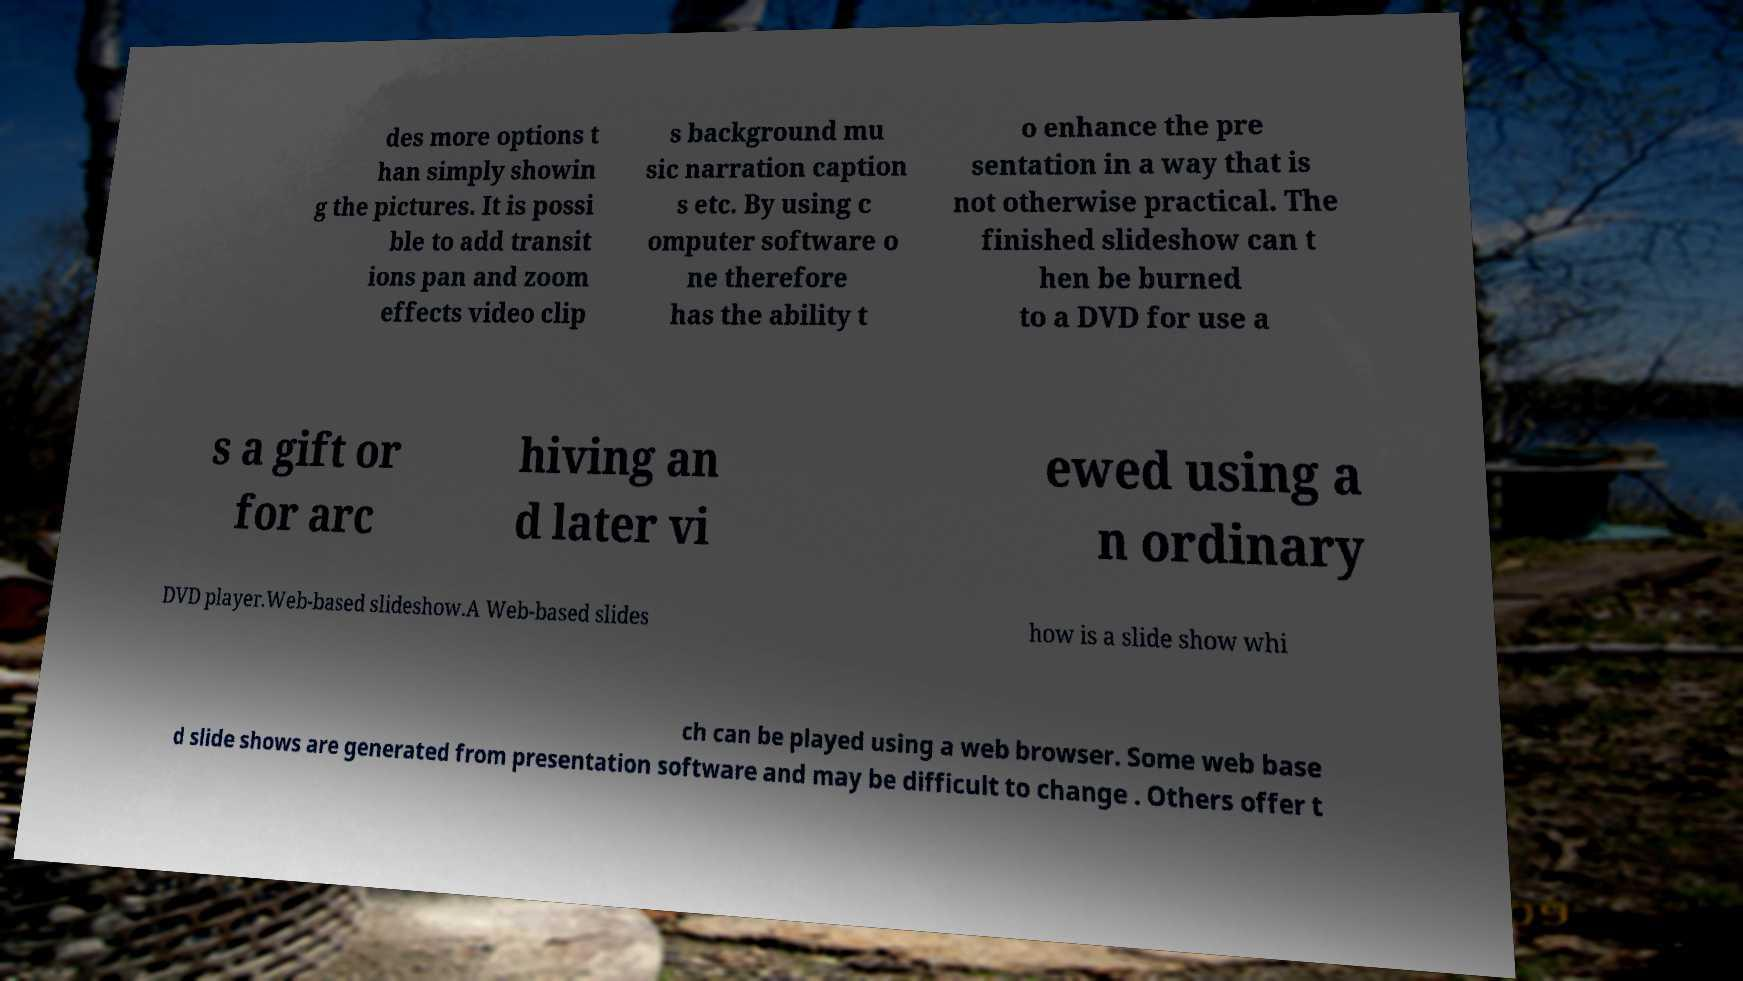What messages or text are displayed in this image? I need them in a readable, typed format. des more options t han simply showin g the pictures. It is possi ble to add transit ions pan and zoom effects video clip s background mu sic narration caption s etc. By using c omputer software o ne therefore has the ability t o enhance the pre sentation in a way that is not otherwise practical. The finished slideshow can t hen be burned to a DVD for use a s a gift or for arc hiving an d later vi ewed using a n ordinary DVD player.Web-based slideshow.A Web-based slides how is a slide show whi ch can be played using a web browser. Some web base d slide shows are generated from presentation software and may be difficult to change . Others offer t 